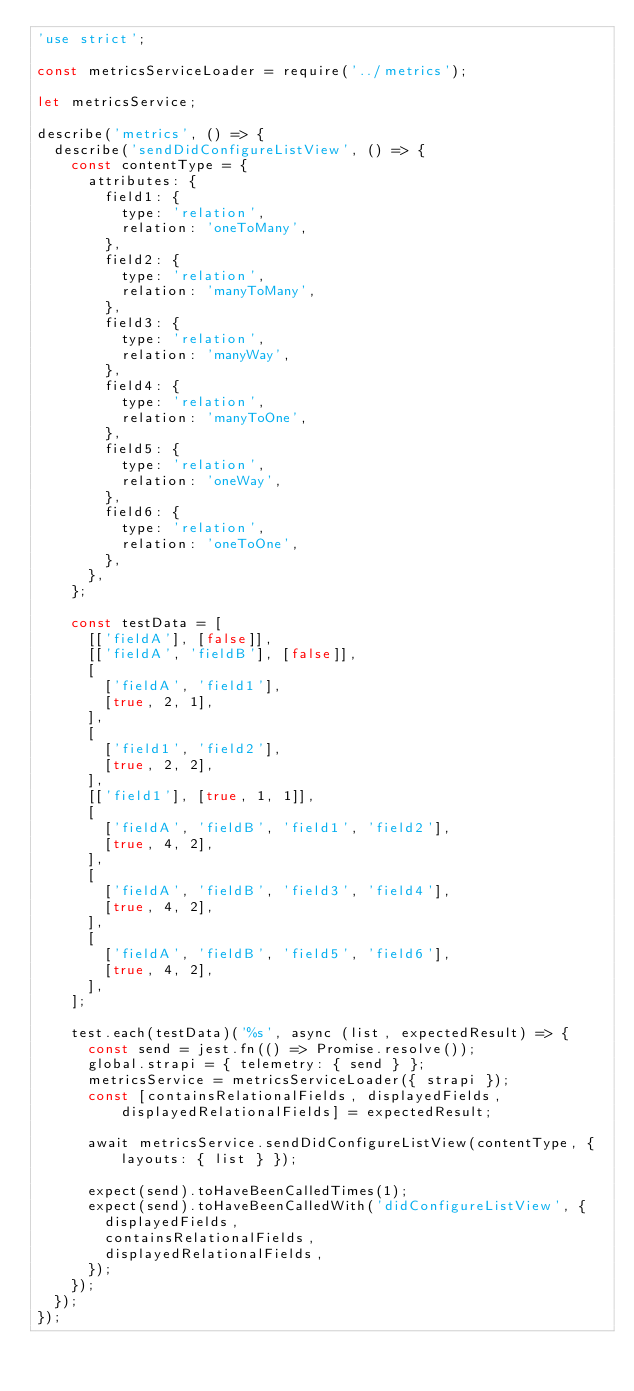Convert code to text. <code><loc_0><loc_0><loc_500><loc_500><_JavaScript_>'use strict';

const metricsServiceLoader = require('../metrics');

let metricsService;

describe('metrics', () => {
  describe('sendDidConfigureListView', () => {
    const contentType = {
      attributes: {
        field1: {
          type: 'relation',
          relation: 'oneToMany',
        },
        field2: {
          type: 'relation',
          relation: 'manyToMany',
        },
        field3: {
          type: 'relation',
          relation: 'manyWay',
        },
        field4: {
          type: 'relation',
          relation: 'manyToOne',
        },
        field5: {
          type: 'relation',
          relation: 'oneWay',
        },
        field6: {
          type: 'relation',
          relation: 'oneToOne',
        },
      },
    };

    const testData = [
      [['fieldA'], [false]],
      [['fieldA', 'fieldB'], [false]],
      [
        ['fieldA', 'field1'],
        [true, 2, 1],
      ],
      [
        ['field1', 'field2'],
        [true, 2, 2],
      ],
      [['field1'], [true, 1, 1]],
      [
        ['fieldA', 'fieldB', 'field1', 'field2'],
        [true, 4, 2],
      ],
      [
        ['fieldA', 'fieldB', 'field3', 'field4'],
        [true, 4, 2],
      ],
      [
        ['fieldA', 'fieldB', 'field5', 'field6'],
        [true, 4, 2],
      ],
    ];

    test.each(testData)('%s', async (list, expectedResult) => {
      const send = jest.fn(() => Promise.resolve());
      global.strapi = { telemetry: { send } };
      metricsService = metricsServiceLoader({ strapi });
      const [containsRelationalFields, displayedFields, displayedRelationalFields] = expectedResult;

      await metricsService.sendDidConfigureListView(contentType, { layouts: { list } });

      expect(send).toHaveBeenCalledTimes(1);
      expect(send).toHaveBeenCalledWith('didConfigureListView', {
        displayedFields,
        containsRelationalFields,
        displayedRelationalFields,
      });
    });
  });
});
</code> 